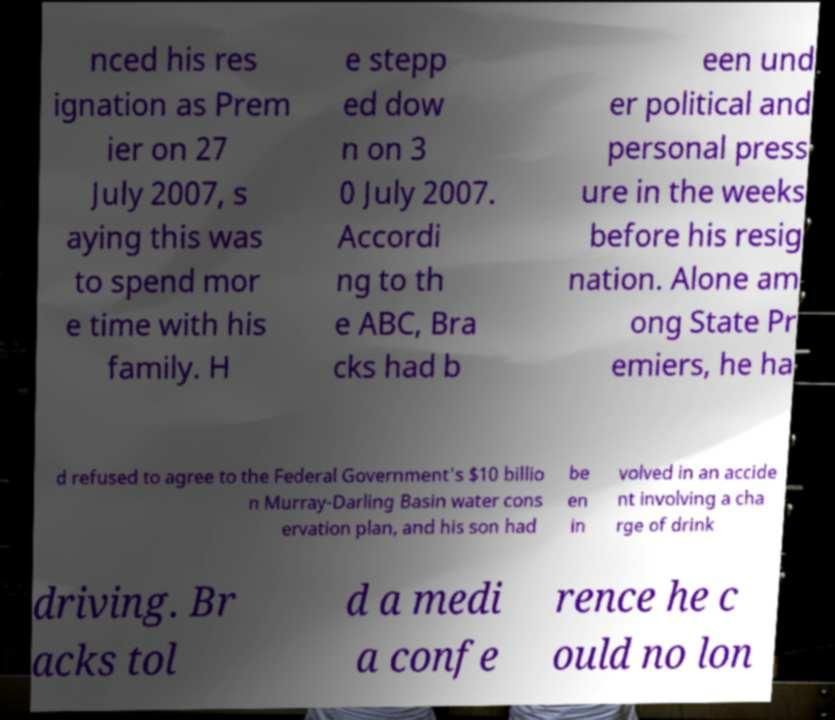What messages or text are displayed in this image? I need them in a readable, typed format. nced his res ignation as Prem ier on 27 July 2007, s aying this was to spend mor e time with his family. H e stepp ed dow n on 3 0 July 2007. Accordi ng to th e ABC, Bra cks had b een und er political and personal press ure in the weeks before his resig nation. Alone am ong State Pr emiers, he ha d refused to agree to the Federal Government's $10 billio n Murray-Darling Basin water cons ervation plan, and his son had be en in volved in an accide nt involving a cha rge of drink driving. Br acks tol d a medi a confe rence he c ould no lon 